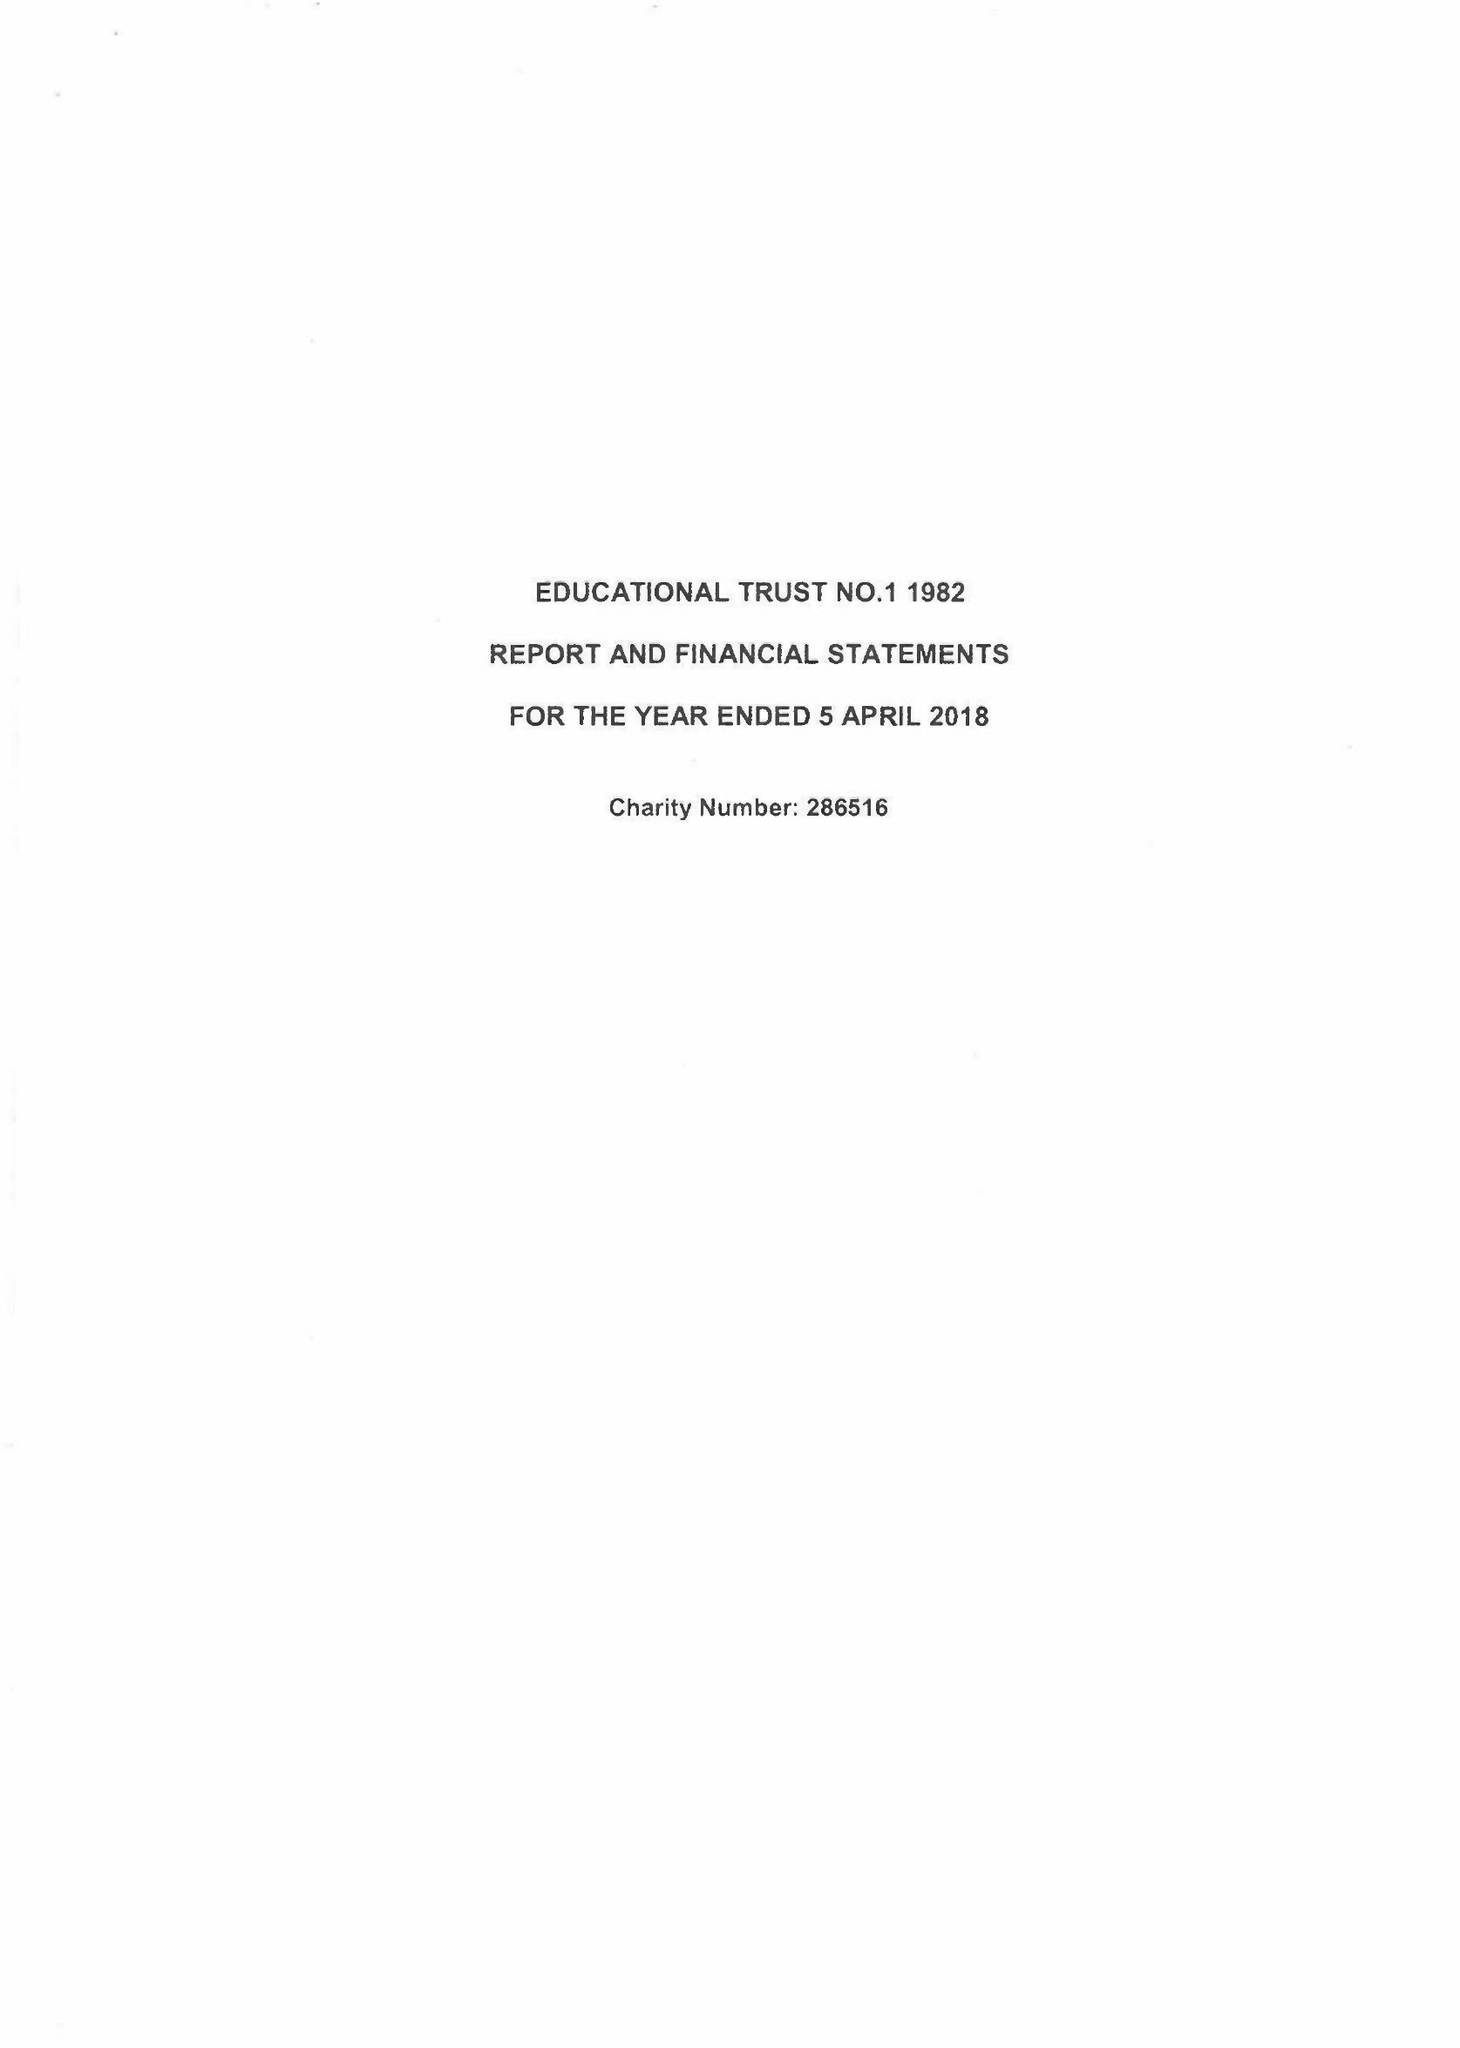What is the value for the address__postcode?
Answer the question using a single word or phrase. PO15 7PA 